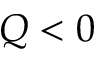Convert formula to latex. <formula><loc_0><loc_0><loc_500><loc_500>Q < 0</formula> 